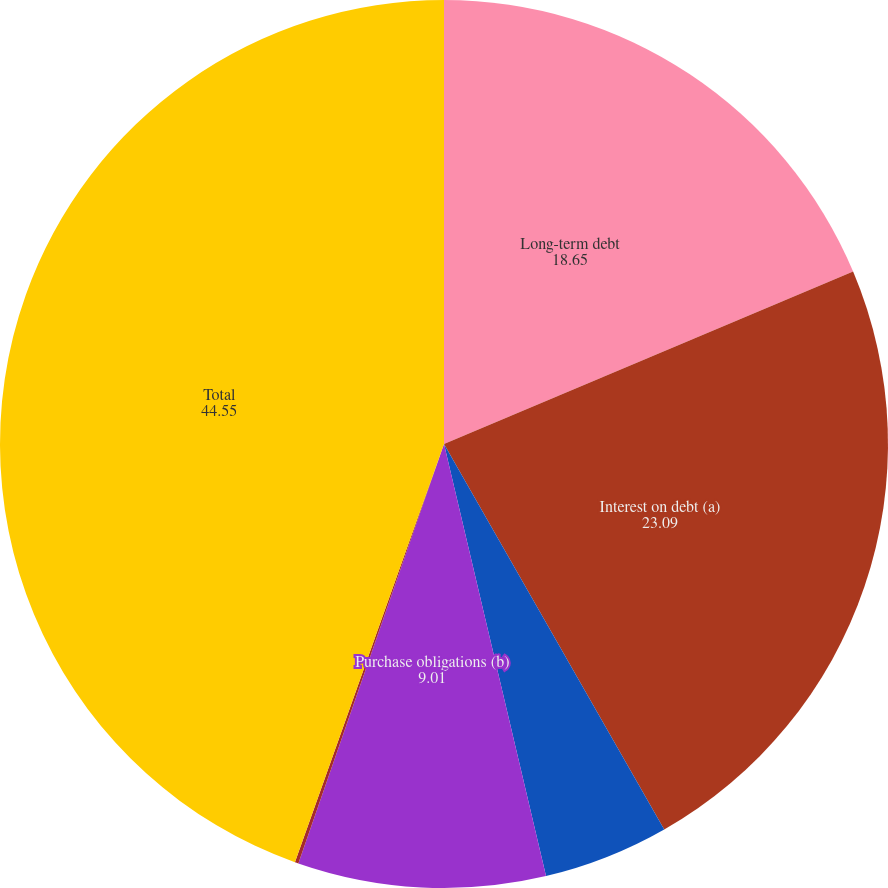<chart> <loc_0><loc_0><loc_500><loc_500><pie_chart><fcel>Long-term debt<fcel>Interest on debt (a)<fcel>Operating leases<fcel>Purchase obligations (b)<fcel>Other long-term liabilities<fcel>Total<nl><fcel>18.65%<fcel>23.09%<fcel>4.57%<fcel>9.01%<fcel>0.13%<fcel>44.55%<nl></chart> 